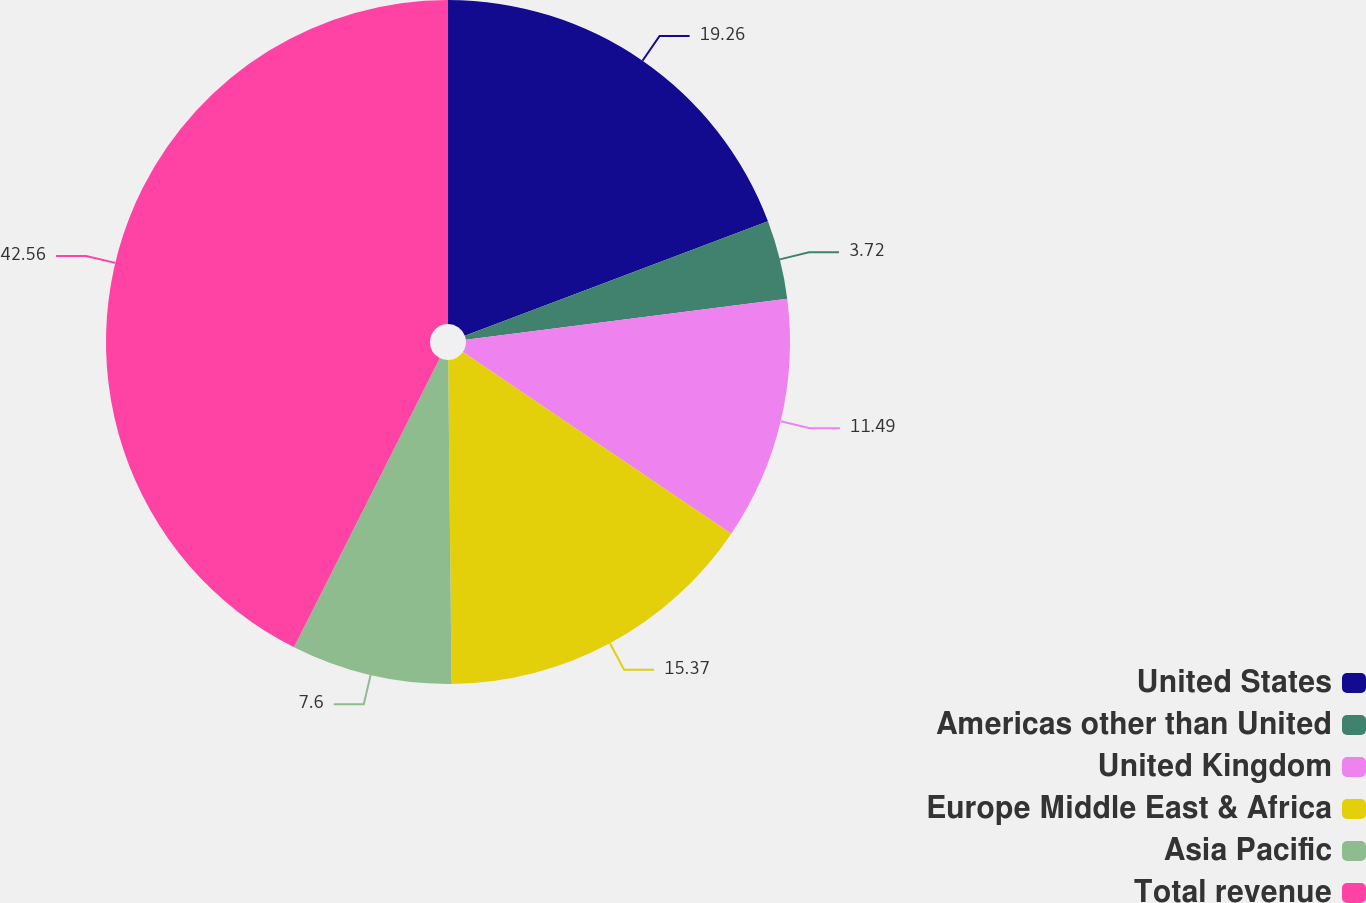Convert chart to OTSL. <chart><loc_0><loc_0><loc_500><loc_500><pie_chart><fcel>United States<fcel>Americas other than United<fcel>United Kingdom<fcel>Europe Middle East & Africa<fcel>Asia Pacific<fcel>Total revenue<nl><fcel>19.26%<fcel>3.72%<fcel>11.49%<fcel>15.37%<fcel>7.6%<fcel>42.57%<nl></chart> 